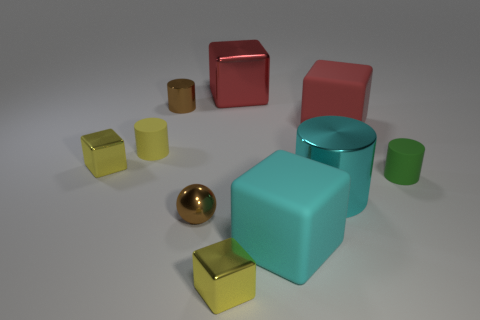Are there any matte objects that have the same color as the tiny sphere?
Keep it short and to the point. No. What number of things are tiny yellow things that are behind the metallic sphere or yellow metal blocks behind the green cylinder?
Offer a terse response. 2. There is a tiny yellow block that is behind the cyan matte block; are there any large red objects that are behind it?
Offer a very short reply. Yes. What is the shape of the brown thing that is the same size as the metal sphere?
Provide a short and direct response. Cylinder. What number of objects are large matte blocks that are right of the big cyan metallic thing or tiny red metallic blocks?
Offer a terse response. 1. How many other objects are there of the same material as the brown ball?
Your answer should be very brief. 5. There is a big rubber thing that is the same color as the large shiny cylinder; what is its shape?
Provide a short and direct response. Cube. What size is the rubber cylinder to the right of the cyan matte object?
Provide a succinct answer. Small. There is a red thing that is made of the same material as the cyan cylinder; what is its shape?
Provide a succinct answer. Cube. Are the brown cylinder and the tiny cylinder on the left side of the tiny brown metallic cylinder made of the same material?
Make the answer very short. No. 